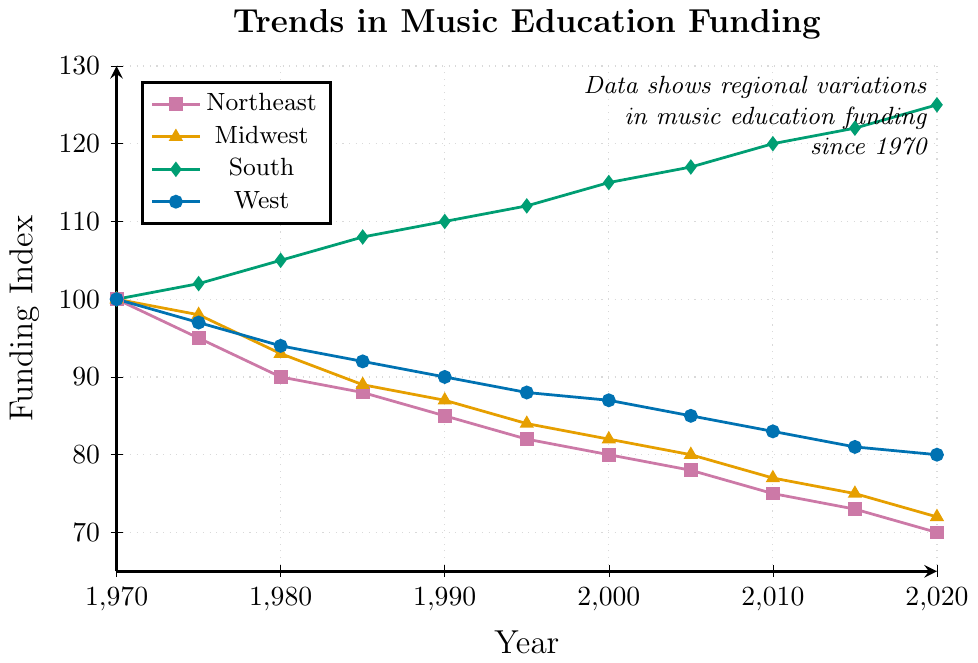Which region had the highest funding index in 2020? Look at the y-values for the year 2020 for all regions. The South has the highest funding index with a value of 125.
Answer: South What was the funding index for the Midwest in 1995 and how does it compare to the Northeast in the same year? The y-value for the Midwest in 1995 is 84 and for the Northeast, it is 82. The Midwest's funding index was higher than the Northeast's by a value of 2.
Answer: Midwest's funding is 2 higher than Northeast's Which region showed an increasing trend in funding index since 1970? Review the lines representing each region. Only the South shows a continuous increase in funding index from 100 in 1970 to 125 in 2020.
Answer: South What is the cumulative difference in funding index between the South and the West from 1970 to 2020? Compute the difference in funding index for each year between the South and the West, then sum these differences. The differences are: 0, 5, 11, 16, 20, 24, 28, 32, 37, 41, 45. The cumulative difference is 259.
Answer: 259 Which region showed the steepest decline in funding index over the given period? Compare the slopes of the lines representing each region. The Northeast declined from 100 in 1970 to 70 in 2020, the steepest decline of 30 points.
Answer: Northeast How did the funding index for the West change from 2000 to 2015? Look at the y-values for the West in 2000 and 2015. The funding index decreased from 87 in 2000 to 81 in 2015.
Answer: Decreased by 6 In which year did the South’s funding index first surpass 110? Trace the y-values for the South to find the year when they first exceed 110. This happens in 1990.
Answer: 1990 Calculate the average funding index of the Midwest from 1970 to 2020. Sum the y-values for the Midwest and divide by the number of years. (100 + 98 + 93 + 89 + 87 + 84 + 82 + 80 + 77 + 75 + 72) / 11 = 84.09
Answer: 84.09 Compare the funding index trend between the Northeast and the Midwest. Examine the slopes of the lines for both regions. Both show a declining trend, but the Northeast has a steeper decline (from 100 to 70) compared to the Midwest (from 100 to 72).
Answer: Both decline, Northeast steeper 